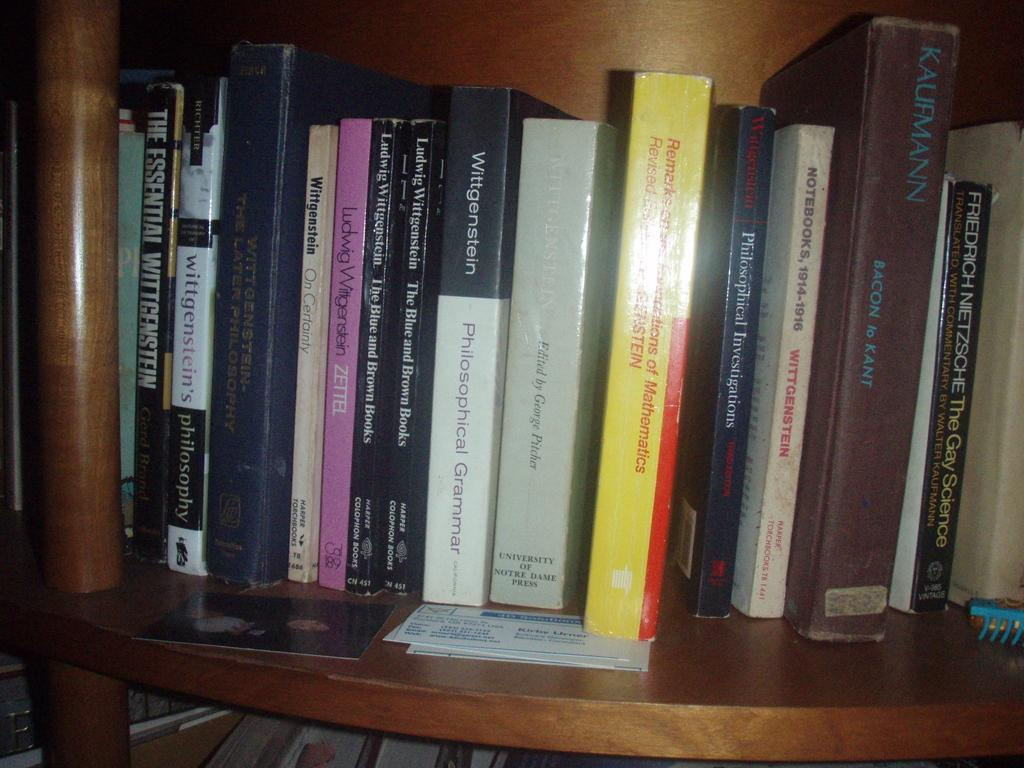<image>
Share a concise interpretation of the image provided. A stack of books on a shelf including Philosophical Grammar by Wittgenstein 